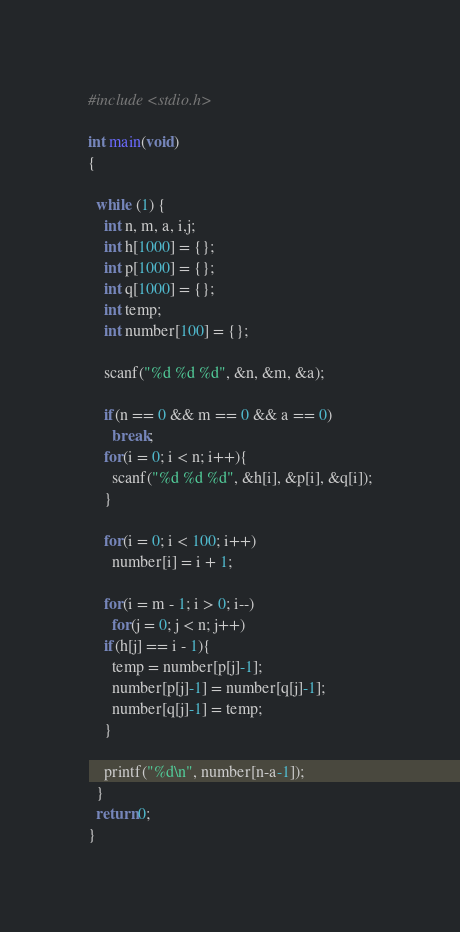Convert code to text. <code><loc_0><loc_0><loc_500><loc_500><_C_>#include <stdio.h>

int main(void)
{

  while (1) {
    int n, m, a, i,j;
    int h[1000] = {};
    int p[1000] = {};
    int q[1000] = {};
    int temp;
    int number[100] = {};

    scanf("%d %d %d", &n, &m, &a);

    if(n == 0 && m == 0 && a == 0)
      break;
    for(i = 0; i < n; i++){
      scanf("%d %d %d", &h[i], &p[i], &q[i]);
    }

    for(i = 0; i < 100; i++)
      number[i] = i + 1;

    for(i = m - 1; i > 0; i--)
      for(j = 0; j < n; j++)
	if(h[j] == i - 1){
	  temp = number[p[j]-1];
	  number[p[j]-1] = number[q[j]-1];
	  number[q[j]-1] = temp;
	}

    printf("%d\n", number[n-a-1]);
  }
  return 0;
}</code> 